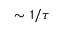Convert formula to latex. <formula><loc_0><loc_0><loc_500><loc_500>\sim 1 / \tau</formula> 